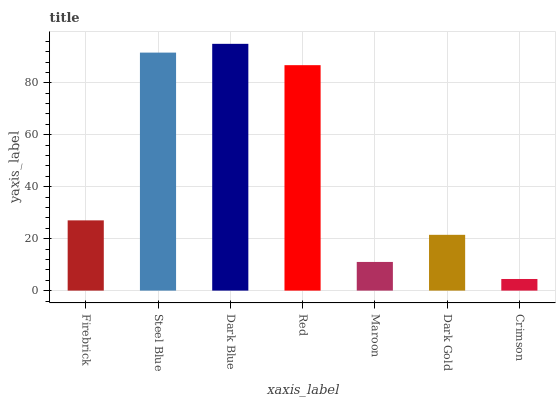Is Crimson the minimum?
Answer yes or no. Yes. Is Dark Blue the maximum?
Answer yes or no. Yes. Is Steel Blue the minimum?
Answer yes or no. No. Is Steel Blue the maximum?
Answer yes or no. No. Is Steel Blue greater than Firebrick?
Answer yes or no. Yes. Is Firebrick less than Steel Blue?
Answer yes or no. Yes. Is Firebrick greater than Steel Blue?
Answer yes or no. No. Is Steel Blue less than Firebrick?
Answer yes or no. No. Is Firebrick the high median?
Answer yes or no. Yes. Is Firebrick the low median?
Answer yes or no. Yes. Is Red the high median?
Answer yes or no. No. Is Maroon the low median?
Answer yes or no. No. 